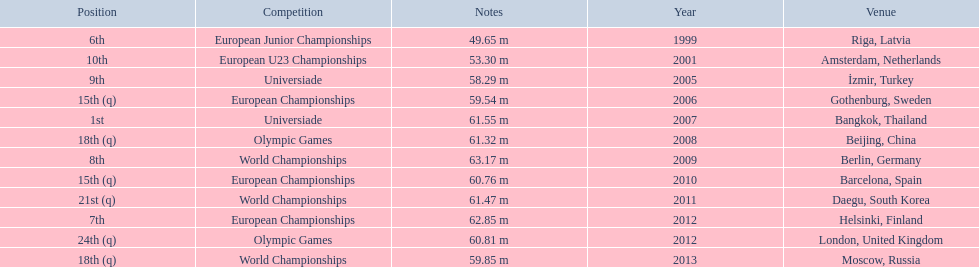What are the years listed prior to 2007? 1999, 2001, 2005, 2006. What are their corresponding finishes? 6th, 10th, 9th, 15th (q). Which is the highest? 6th. 